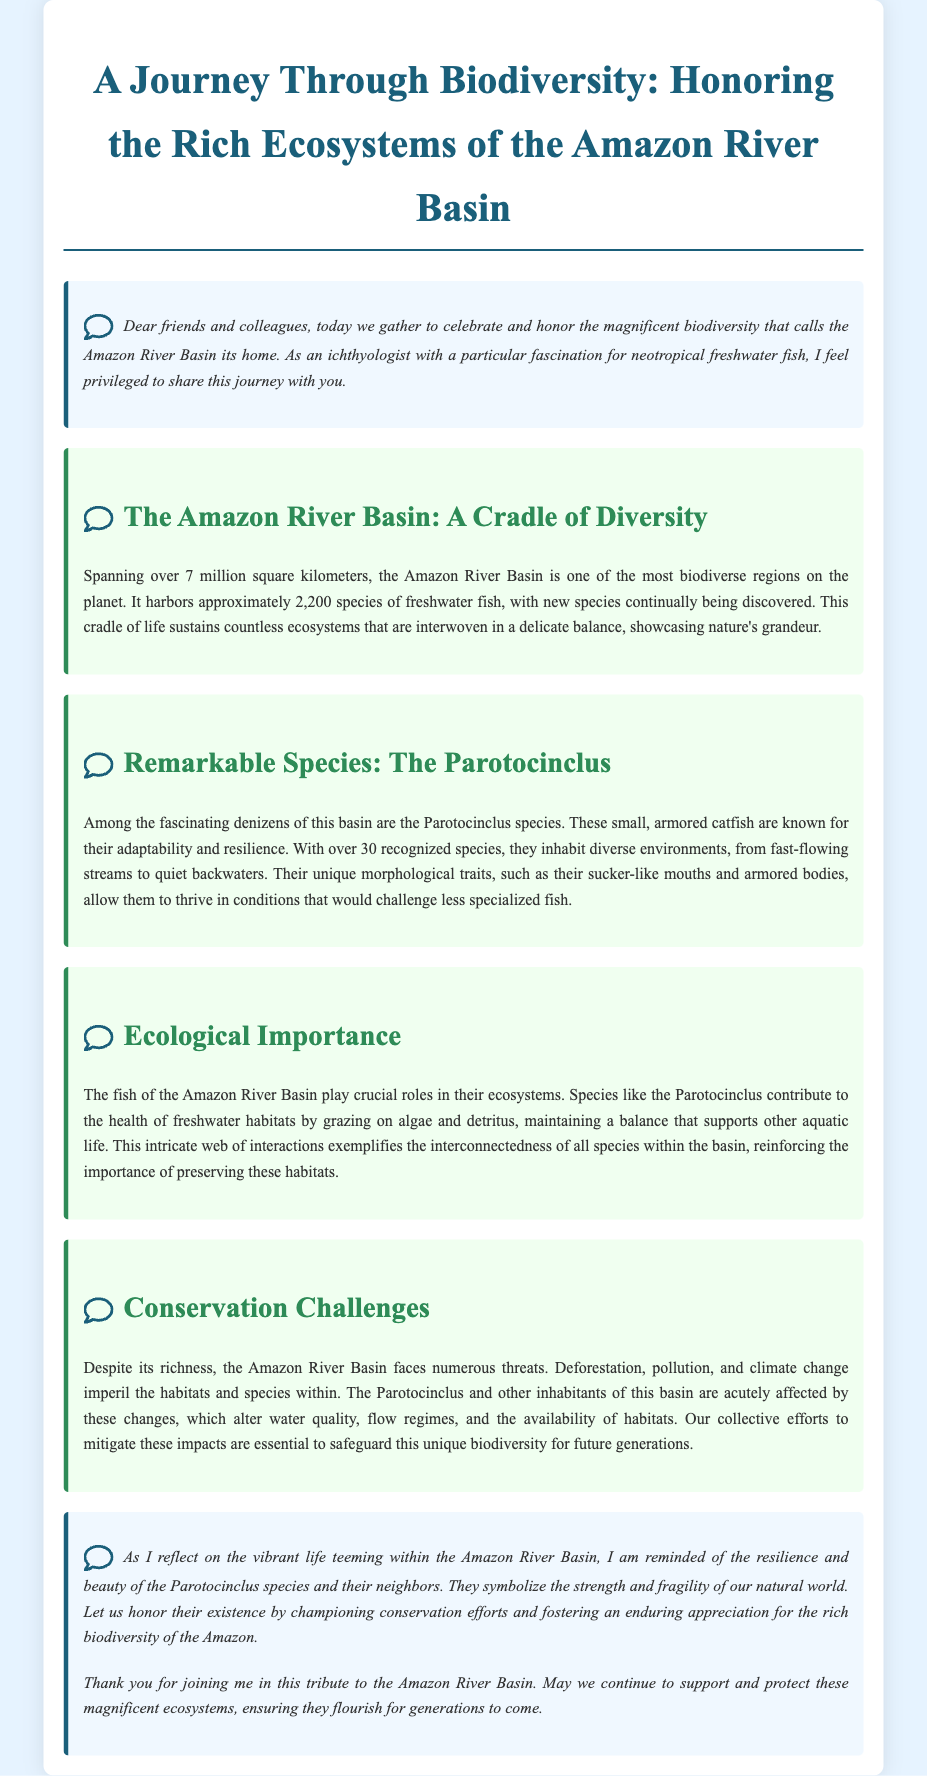What is the area of the Amazon River Basin? The document states that the Amazon River Basin spans over 7 million square kilometers.
Answer: 7 million square kilometers How many species of freshwater fish does the Amazon River Basin have? The document mentions that the Amazon River Basin harbors approximately 2,200 species of freshwater fish.
Answer: 2,200 species How many recognized species of Parotocinclus are there? The document indicates that there are over 30 recognized species of Parotocinclus.
Answer: Over 30 What role do species like Parotocinclus play in their ecosystems? The document notes that they contribute to the health of freshwater habitats by grazing on algae and detritus.
Answer: Grazing on algae and detritus What are three threats faced by the Amazon River Basin? The document lists deforestation, pollution, and climate change as threats to the Amazon River Basin.
Answer: Deforestation, pollution, climate change What is the main theme of the eulogy? The document emphasizes the importance of honoring and preserving the rich biodiversity of the Amazon River Basin.
Answer: Honoring and preserving biodiversity What does the author symbolize through Parotocinclus species? The author reflects that Parotocinclus symbolizes the strength and fragility of our natural world.
Answer: Strength and fragility of our natural world What type of document is this? The document is a eulogy that honors the biodiversity of the Amazon River Basin.
Answer: Eulogy 